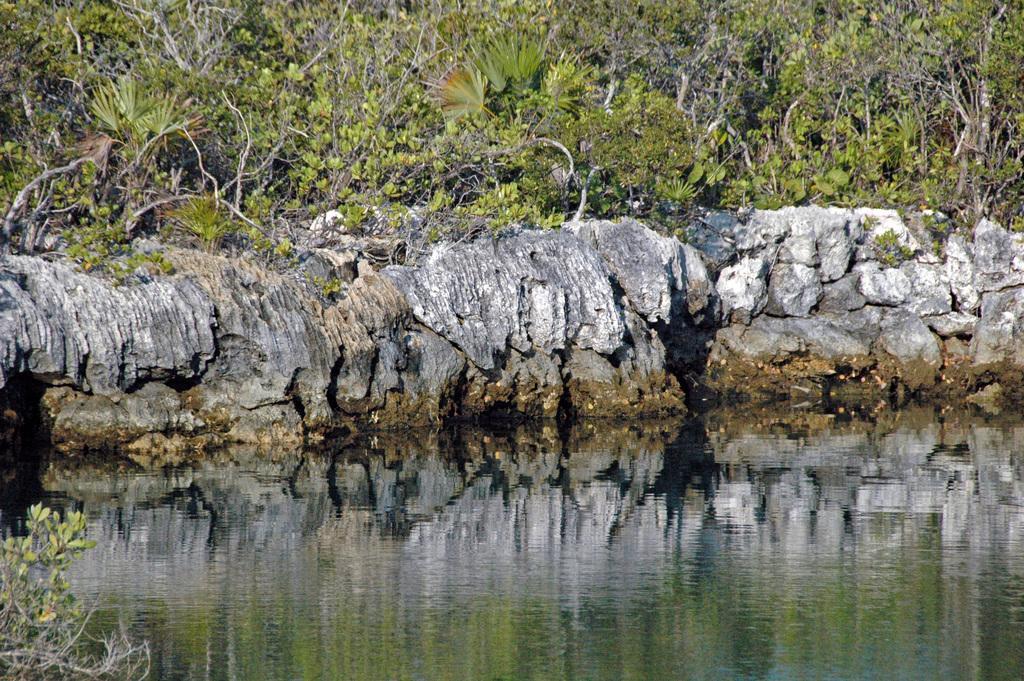How would you summarize this image in a sentence or two? In this image, we can see rocks and trees and at the bottom, there is water. 